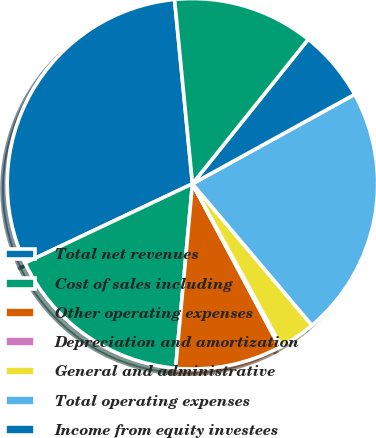Convert chart. <chart><loc_0><loc_0><loc_500><loc_500><pie_chart><fcel>Total net revenues<fcel>Cost of sales including<fcel>Other operating expenses<fcel>Depreciation and amortization<fcel>General and administrative<fcel>Total operating expenses<fcel>Income from equity investees<fcel>Operating income<nl><fcel>30.49%<fcel>16.52%<fcel>9.26%<fcel>0.16%<fcel>3.19%<fcel>21.86%<fcel>6.23%<fcel>12.29%<nl></chart> 